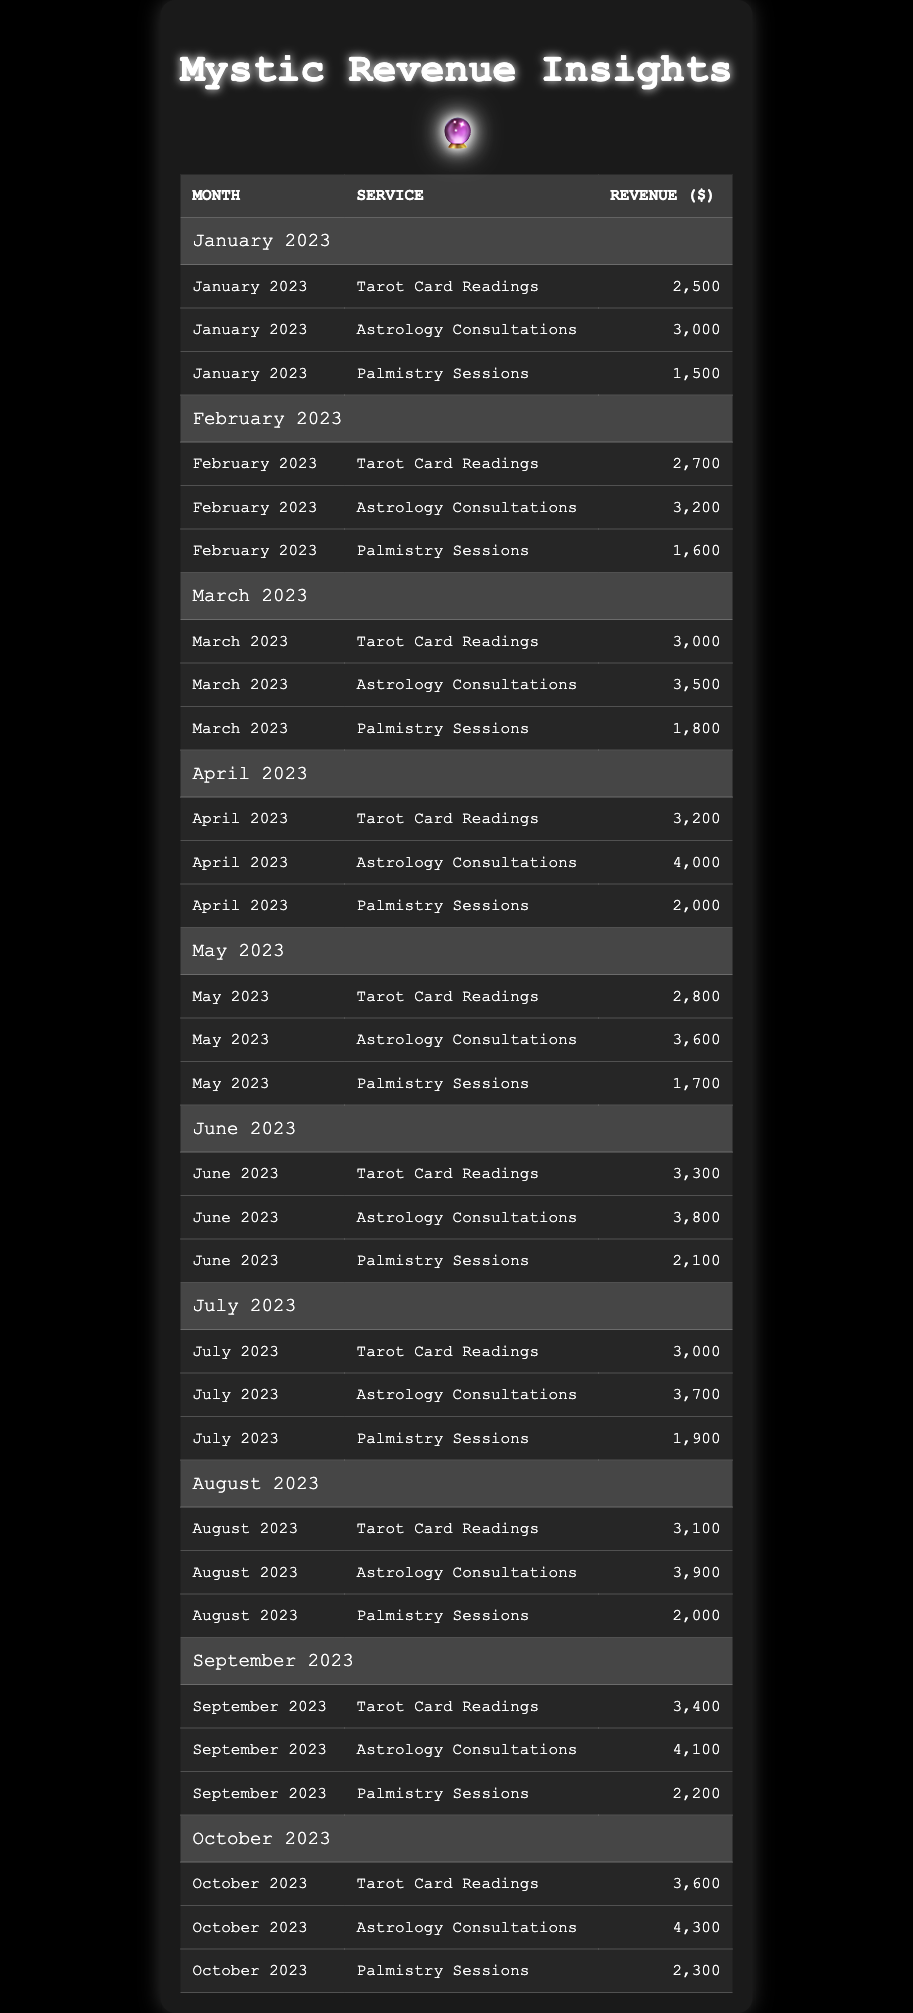What was the total revenue from Tarot Card Readings in March 2023? The revenue for Tarot Card Readings in March 2023 is listed as $3,000.
Answer: $3,000 What is the monthly revenue for Palmistry Sessions in October 2023? The revenue for Palmistry Sessions in October 2023 is listed as $2,300.
Answer: $2,300 Is the revenue from Astrology Consultations in April higher than in February? The revenue for Astrology Consultations in April 2023 is $4,000, while in February 2023 it is $3,200; since $4,000 > $3,200, the statement is true.
Answer: Yes Which month had the highest revenue for Tarot Card Readings? By scanning the table, April 2023 has the highest revenue for Tarot Card Readings at $3,200.
Answer: April 2023 What is the average revenue from Palmistry Sessions over the year? The total revenue for Palmistry Sessions is the sum: (1,500 + 1,600 + 1,800 + 2,000 + 1,700 + 2,100 + 1,900 + 2,000 + 2,200 + 2,300) = 19,100. There are 10 months, so the average is 19,100 / 10 = 1,910.
Answer: $1,910 In which month was the revenue from Astrology Consultations lower than $4,000? By checking the data, the months of January 2023 ($3,000), February 2023 ($3,200), and March 2023 ($3,500) all had revenues lower than $4,000.
Answer: January, February, March Calculate the difference between the maximum and minimum monthly revenue obtained from Tarot Card Readings. The maximum revenue is $3,600 (October 2023), and the minimum is $2,500 (January 2023). The difference is $3,600 - $2,500 = $1,100.
Answer: $1,100 Which service contributed the most to the total revenue in September 2023? The revenues for September 2023 show Tarot Card Readings at $3,400, Astrology Consultations at $4,100, and Palmistry Sessions at $2,200. The highest is $4,100 from Astrology Consultations.
Answer: Astrology Consultations Was there a month where the revenue for all services combined exceeded $10,000? For October 2023, the total revenue is $3,600 + $4,300 + $2,300 = $10,200, which exceeds $10,000. Monthly totals for months such as April and September also exceed this amount.
Answer: Yes What is the revenue growth trend from Tarot Card Readings in the first four months? The revenues are $2,500 (Jan), $2,700 (Feb), $3,000 (Mar), $3,200 (Apr). This shows a steady increase each month: $2,500 < $2,700 < $3,000 < $3,200.
Answer: Growth How much more revenue did Astrology Consultations earn in June compared to May 2023? June revenue is $3,800 and May revenue is $3,600. The difference is $3,800 - $3,600 = $200.
Answer: $200 